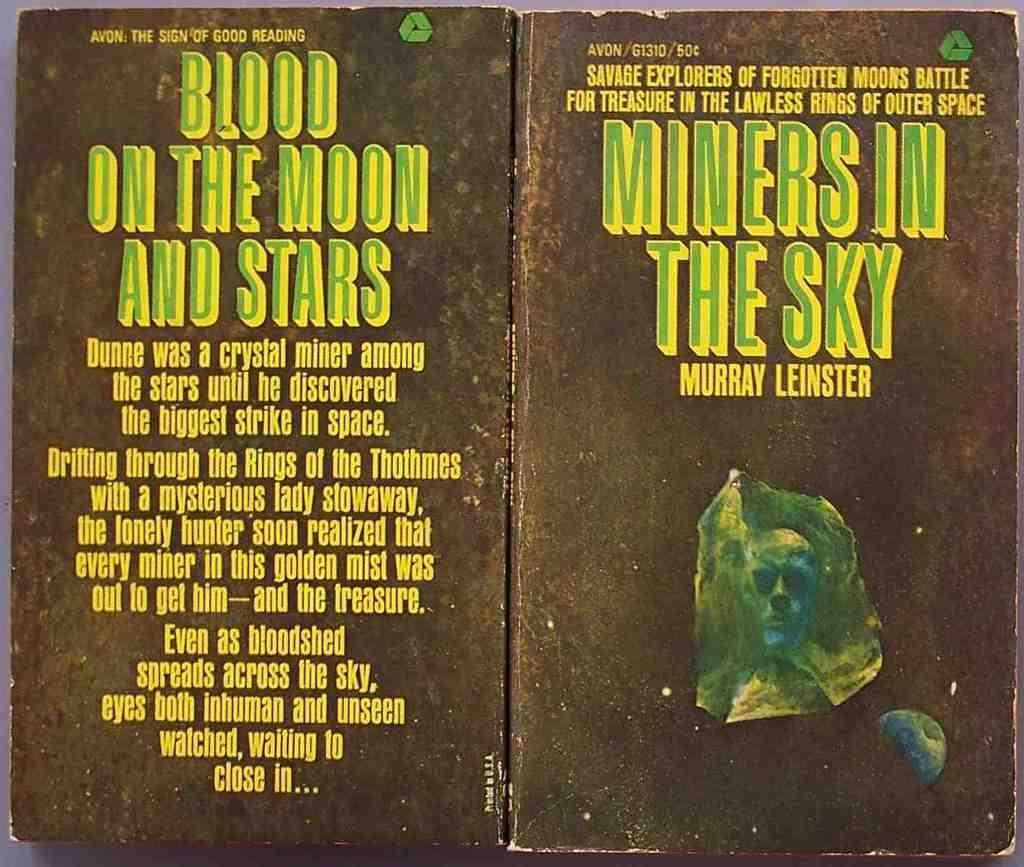Provide a one-sentence caption for the provided image. A copy of the book Miners in the Sky looks a bit worn. 